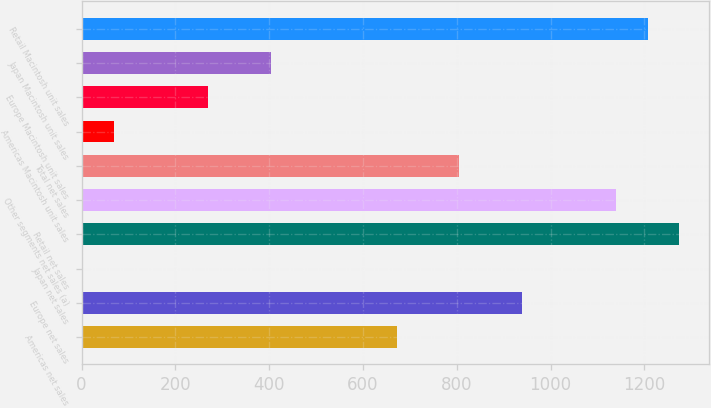Convert chart to OTSL. <chart><loc_0><loc_0><loc_500><loc_500><bar_chart><fcel>Americas net sales<fcel>Europe net sales<fcel>Japan net sales<fcel>Retail net sales<fcel>Other segments net sales (a)<fcel>Total net sales<fcel>Americas Macintosh unit sales<fcel>Europe Macintosh unit sales<fcel>Japan Macintosh unit sales<fcel>Retail Macintosh unit sales<nl><fcel>672<fcel>939.6<fcel>3<fcel>1274.1<fcel>1140.3<fcel>805.8<fcel>69.9<fcel>270.6<fcel>404.4<fcel>1207.2<nl></chart> 